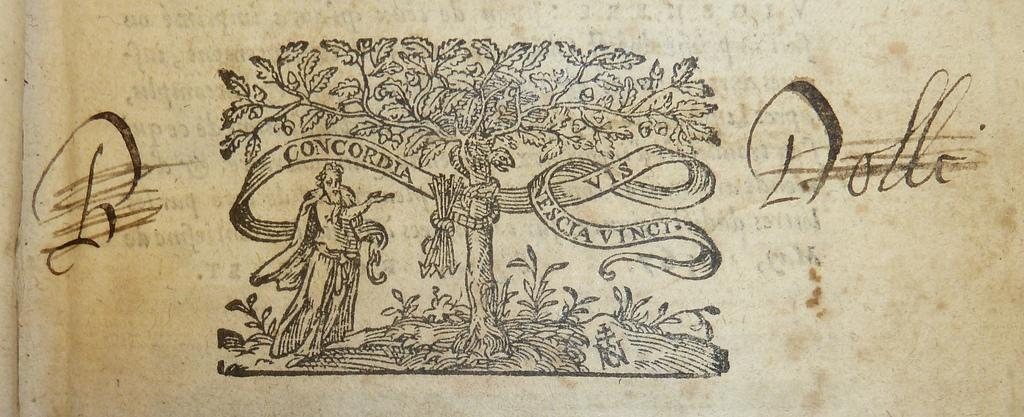What is depicted on the paper in the image? There is a drawing of a tree and a person on the paper. Are there any other elements on the paper besides the drawings? Yes, there is writing on the paper at a few places. How many islands can be seen in the drawing of the person? There are no islands depicted in the drawing of the person, as the image only shows a drawing of a person and a tree on a paper. 